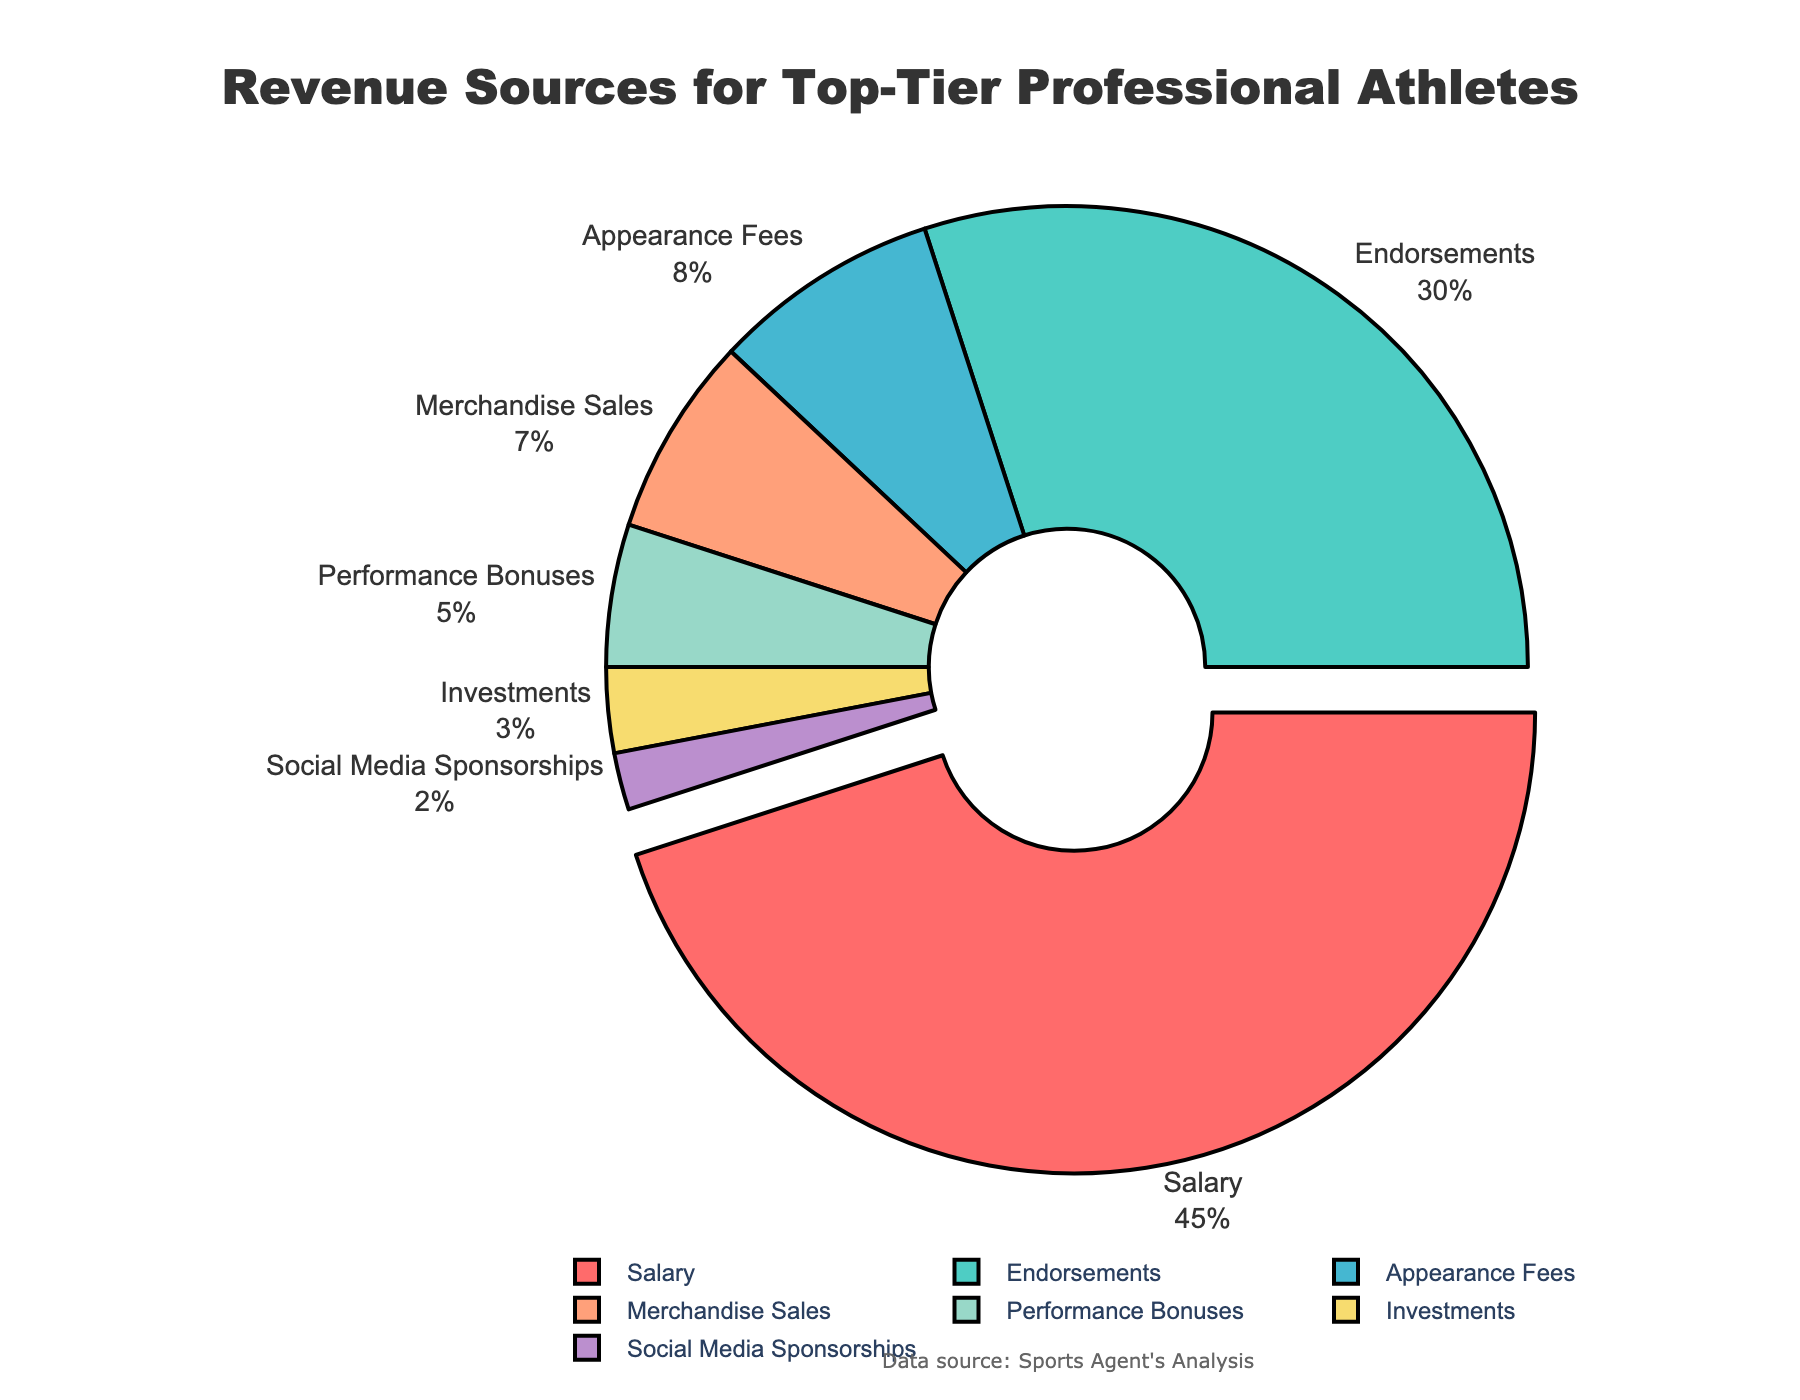Which revenue source represents the largest percentage for top-tier professional athletes? The pie chart shows various revenue sources for top-tier professional athletes, and by looking at the percentage values, Salary has the largest percentage.
Answer: Salary What is the combined percentage of Endorsements and Appearance Fees? According to the pie chart, Endorsements have 30% and Appearance Fees have 8%. Adding these together gives 30% + 8% = 38%.
Answer: 38% Which has a smaller percentage: Merchandise Sales or Performance Bonuses? By comparing the percentages shown in the pie chart, Performance Bonuses (5%) are smaller than Merchandise Sales (7%).
Answer: Performance Bonuses How much larger is the percentage for Social Media Sponsorships than for Investments? The pie chart shows Social Media Sponsorships at 2% and Investments at 3%. The difference is 3% - 2% = -1%, meaning Social Media Sponsorships are 1% smaller than Investments.
Answer: 1% smaller What is the total percentage for all the revenue sources combined? Sum all the percentages from the pie chart: 45% (Salary) + 30% (Endorsements) + 8% (Appearance Fees) + 7% (Merchandise Sales) + 5% (Performance Bonuses) + 3% (Investments) + 2% (Social Media Sponsorships) = 100%.
Answer: 100% Which revenue source(s) have percentages equal to or less than 5%? From the pie chart, Performance Bonuses are at 5%, Investments at 3%, and Social Media Sponsorships at 2%.
Answer: Performance Bonuses, Investments, Social Media Sponsorships What is the second largest revenue source? Referring to the percentage values in the pie chart, the largest source is Salary (45%) and the second largest is Endorsements (30%).
Answer: Endorsements How much do Appearance Fees, Merchandise Sales, and Performance Bonuses contribute collectively? According to the pie chart, Appearance Fees are 8%, Merchandise Sales are 7%, and Performance Bonuses are 5%. The total is 8% + 7% + 5% = 20%.
Answer: 20% What proportion of revenue comes from non-Salary sources? The total percentage is 100%. Salary is 45%. Thus, non-Salary sources contribute 100% - 45% = 55%.
Answer: 55% 